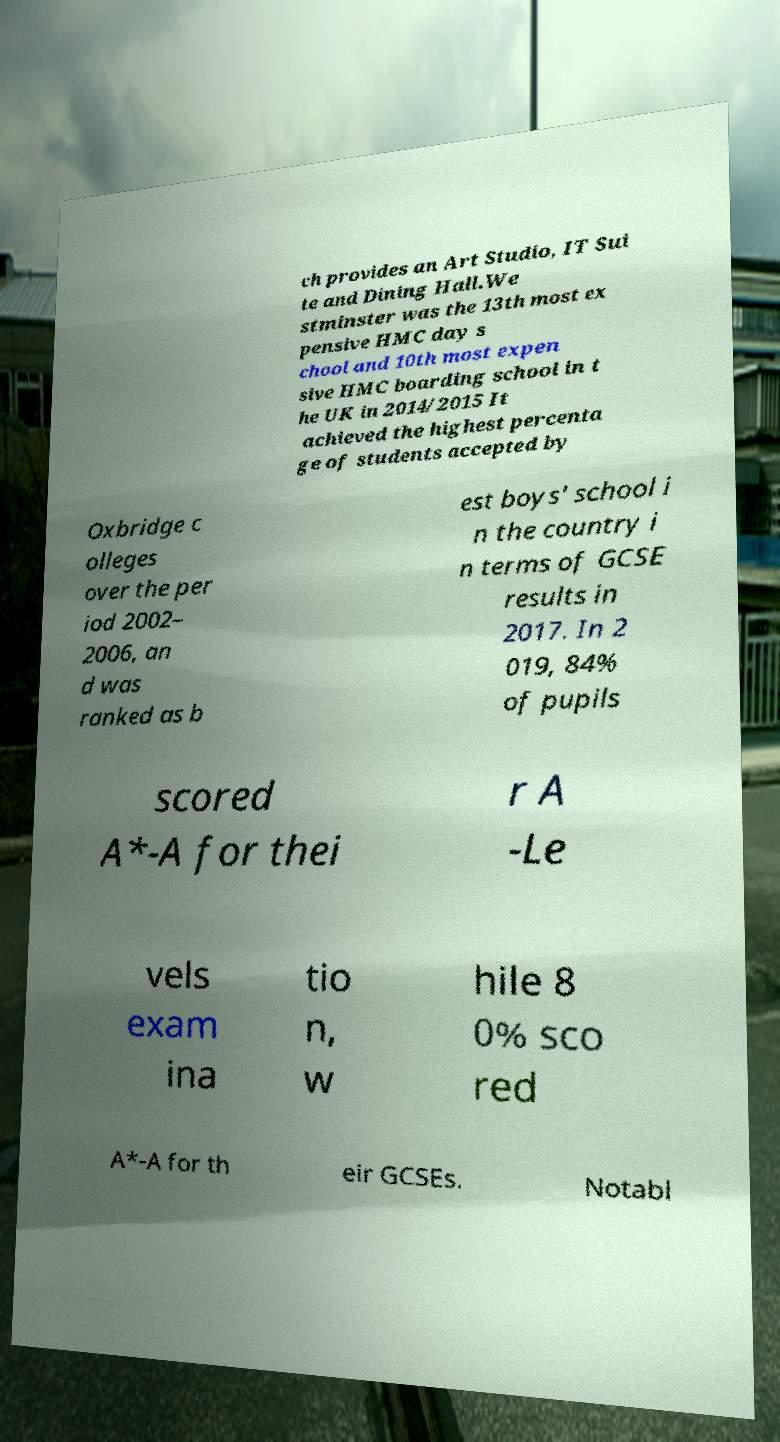Can you accurately transcribe the text from the provided image for me? ch provides an Art Studio, IT Sui te and Dining Hall.We stminster was the 13th most ex pensive HMC day s chool and 10th most expen sive HMC boarding school in t he UK in 2014/2015 It achieved the highest percenta ge of students accepted by Oxbridge c olleges over the per iod 2002– 2006, an d was ranked as b est boys' school i n the country i n terms of GCSE results in 2017. In 2 019, 84% of pupils scored A*-A for thei r A -Le vels exam ina tio n, w hile 8 0% sco red A*-A for th eir GCSEs. Notabl 